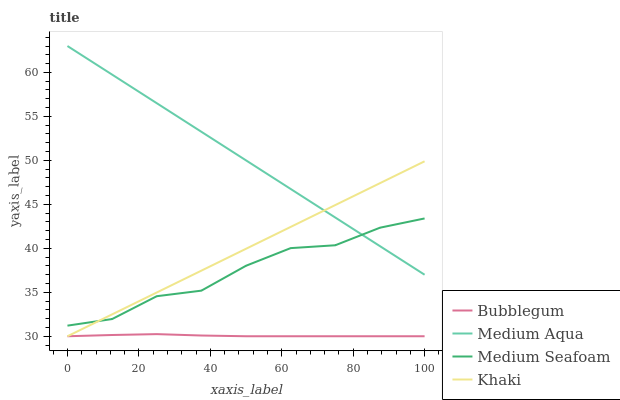Does Medium Seafoam have the minimum area under the curve?
Answer yes or no. No. Does Medium Seafoam have the maximum area under the curve?
Answer yes or no. No. Is Medium Seafoam the smoothest?
Answer yes or no. No. Is Medium Aqua the roughest?
Answer yes or no. No. Does Medium Seafoam have the lowest value?
Answer yes or no. No. Does Medium Seafoam have the highest value?
Answer yes or no. No. Is Bubblegum less than Medium Seafoam?
Answer yes or no. Yes. Is Medium Seafoam greater than Bubblegum?
Answer yes or no. Yes. Does Bubblegum intersect Medium Seafoam?
Answer yes or no. No. 